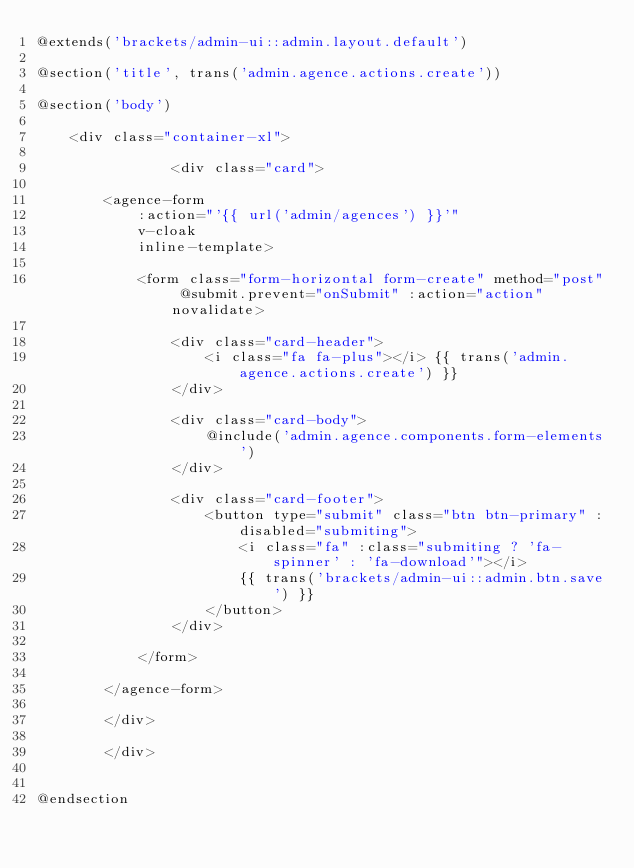Convert code to text. <code><loc_0><loc_0><loc_500><loc_500><_PHP_>@extends('brackets/admin-ui::admin.layout.default')

@section('title', trans('admin.agence.actions.create'))

@section('body')

    <div class="container-xl">

                <div class="card">
        
        <agence-form
            :action="'{{ url('admin/agences') }}'"
            v-cloak
            inline-template>

            <form class="form-horizontal form-create" method="post" @submit.prevent="onSubmit" :action="action" novalidate>
                
                <div class="card-header">
                    <i class="fa fa-plus"></i> {{ trans('admin.agence.actions.create') }}
                </div>

                <div class="card-body">
                    @include('admin.agence.components.form-elements')
                </div>
                                
                <div class="card-footer">
                    <button type="submit" class="btn btn-primary" :disabled="submiting">
                        <i class="fa" :class="submiting ? 'fa-spinner' : 'fa-download'"></i>
                        {{ trans('brackets/admin-ui::admin.btn.save') }}
                    </button>
                </div>
                
            </form>

        </agence-form>

        </div>

        </div>

    
@endsection</code> 